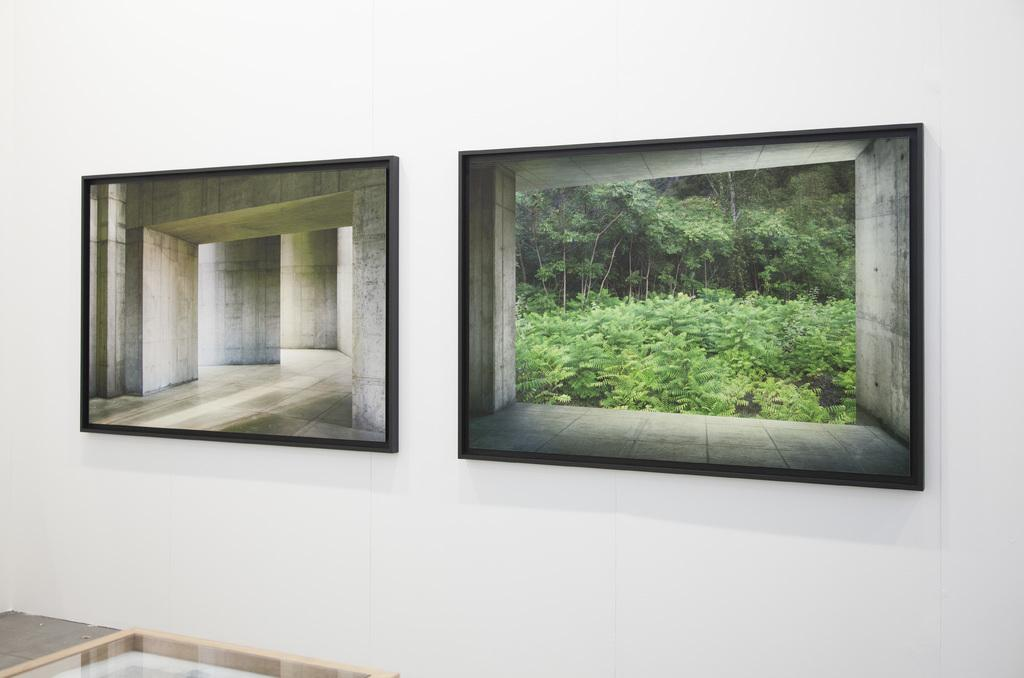What is the color of the wall in the image? The wall in the image is white. How many frames are on the wall? There are two frames on the wall. What is depicted in the first frame? The first frame contains a picture of walls. What is depicted in the second frame? The second frame contains a picture of plants and trees. What type of metal is used to construct the frames in the image? There is no information about the material used to construct the frames in the image. 